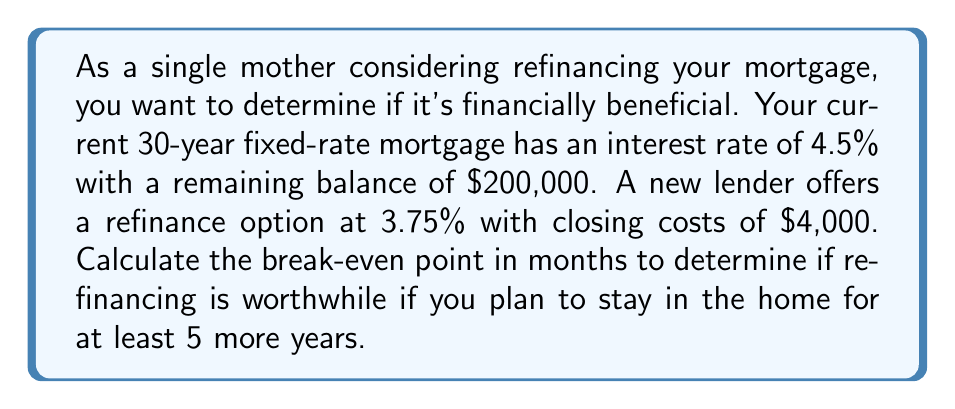Could you help me with this problem? To calculate the break-even point, we need to follow these steps:

1. Calculate the current monthly payment:
   Using the formula: $P = L\frac{r(1+r)^n}{(1+r)^n-1}$
   Where $P$ is the monthly payment, $L$ is the loan amount, $r$ is the monthly interest rate, and $n$ is the number of payments.

   $r = \frac{4.5\%}{12} = 0.00375$
   $n = 30 \times 12 = 360$

   $P = 200,000 \times \frac{0.00375(1+0.00375)^{360}}{(1+0.00375)^{360}-1} = $1,013.37

2. Calculate the new monthly payment:
   Using the same formula with the new interest rate:

   $r = \frac{3.75\%}{12} = 0.003125$

   $P_{new} = 200,000 \times \frac{0.003125(1+0.003125)^{360}}{(1+0.003125)^{360}-1} = $926.23

3. Calculate the monthly savings:
   Monthly savings = Current payment - New payment
   $1,013.37 - $926.23 = $87.14

4. Calculate the break-even point:
   Break-even point = Closing costs ÷ Monthly savings
   $4,000 ÷ $87.14 = 45.90 months

Therefore, it will take approximately 46 months to break even on the refinancing costs.
Answer: 46 months 